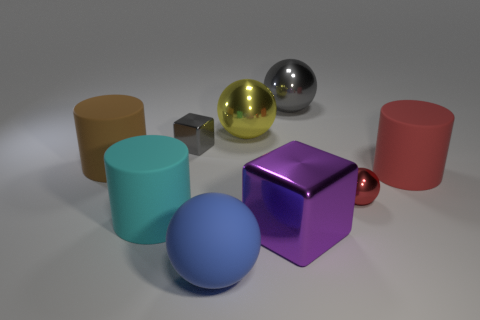Subtract all large brown matte cylinders. How many cylinders are left? 2 Add 1 red spheres. How many objects exist? 10 Subtract all cyan cylinders. How many cylinders are left? 2 Subtract 3 cylinders. How many cylinders are left? 0 Subtract 1 red cylinders. How many objects are left? 8 Subtract all cylinders. How many objects are left? 6 Subtract all red spheres. Subtract all red cylinders. How many spheres are left? 3 Subtract all red rubber cylinders. Subtract all large brown rubber cylinders. How many objects are left? 7 Add 4 blue things. How many blue things are left? 5 Add 4 small brown rubber cubes. How many small brown rubber cubes exist? 4 